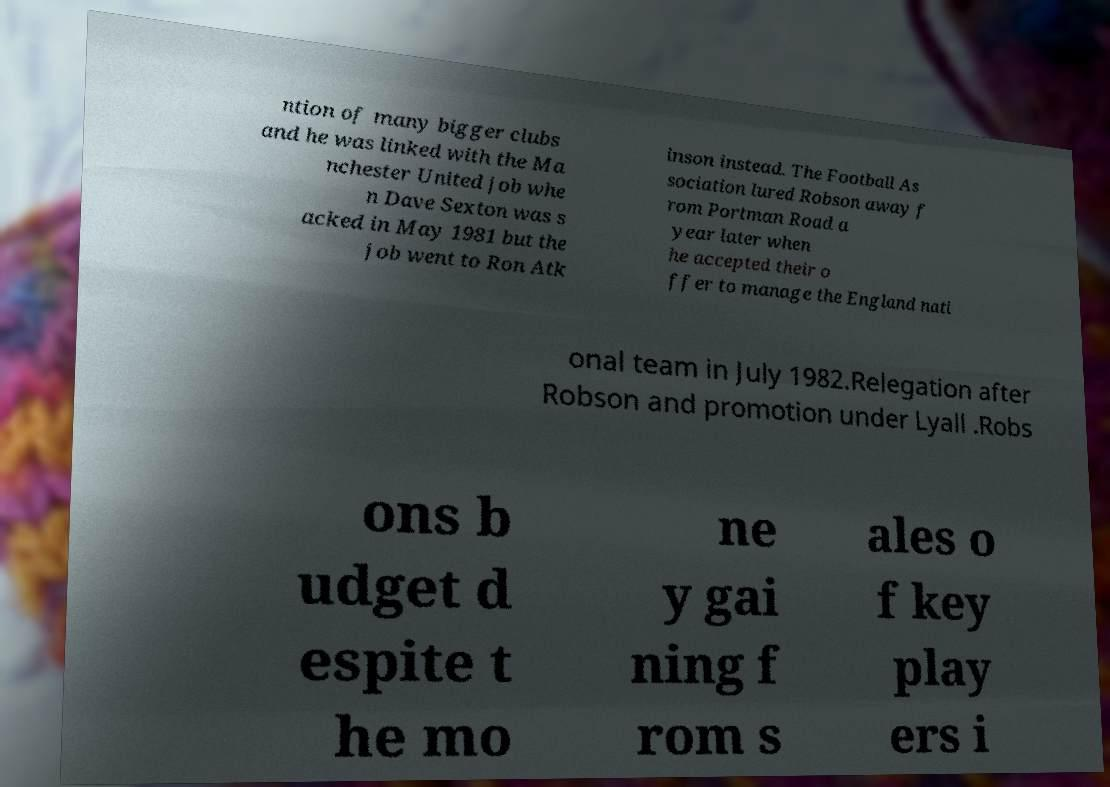Please read and relay the text visible in this image. What does it say? ntion of many bigger clubs and he was linked with the Ma nchester United job whe n Dave Sexton was s acked in May 1981 but the job went to Ron Atk inson instead. The Football As sociation lured Robson away f rom Portman Road a year later when he accepted their o ffer to manage the England nati onal team in July 1982.Relegation after Robson and promotion under Lyall .Robs ons b udget d espite t he mo ne y gai ning f rom s ales o f key play ers i 